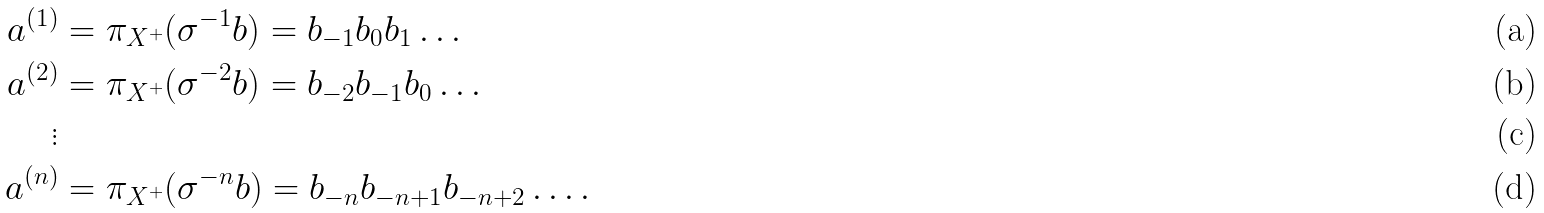<formula> <loc_0><loc_0><loc_500><loc_500>a ^ { ( 1 ) } & = \pi _ { X ^ { + } } ( \sigma ^ { - 1 } b ) = b _ { - 1 } b _ { 0 } b _ { 1 } \dots \\ a ^ { ( 2 ) } & = \pi _ { X ^ { + } } ( \sigma ^ { - 2 } b ) = b _ { - 2 } b _ { - 1 } b _ { 0 } \dots \\ \vdots \\ a ^ { ( n ) } & = \pi _ { X ^ { + } } ( \sigma ^ { - n } b ) = b _ { - n } b _ { - n + 1 } b _ { - n + 2 } \dots .</formula> 